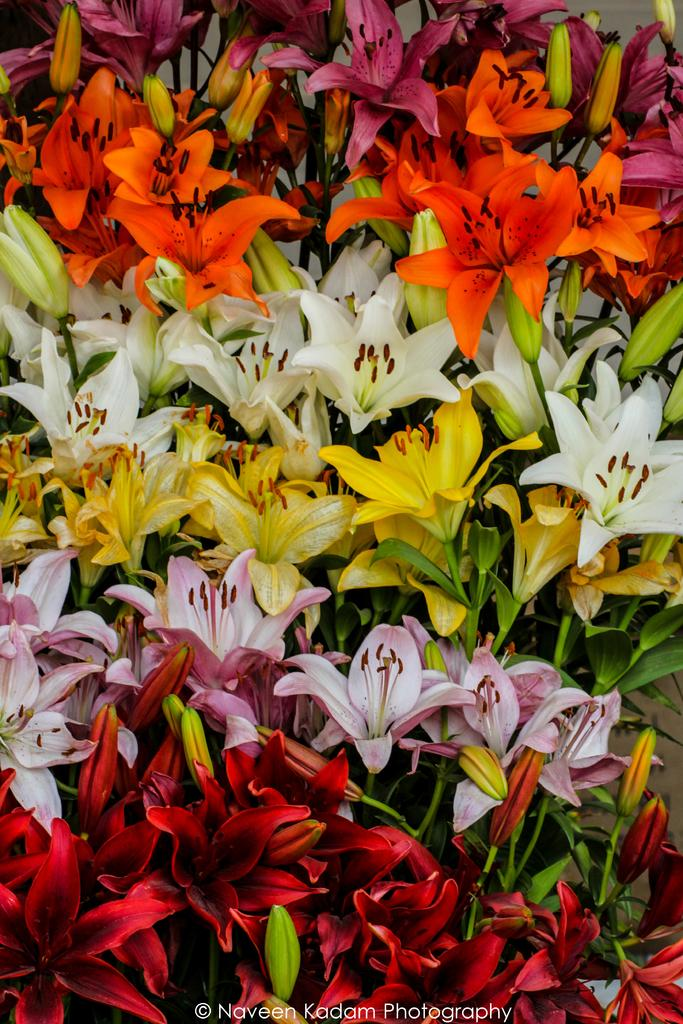What type of living organisms can be seen in the image? There are flowers in the image. What colors are the flowers in the image? The flowers are in red, pink, yellow, white, and orange colors. What type of fruit is hanging from the flowers in the image? There is no fruit present in the image; it only features flowers of various colors. What hobbies do the flowers have in the image? Flowers do not have hobbies, as they are inanimate objects. 